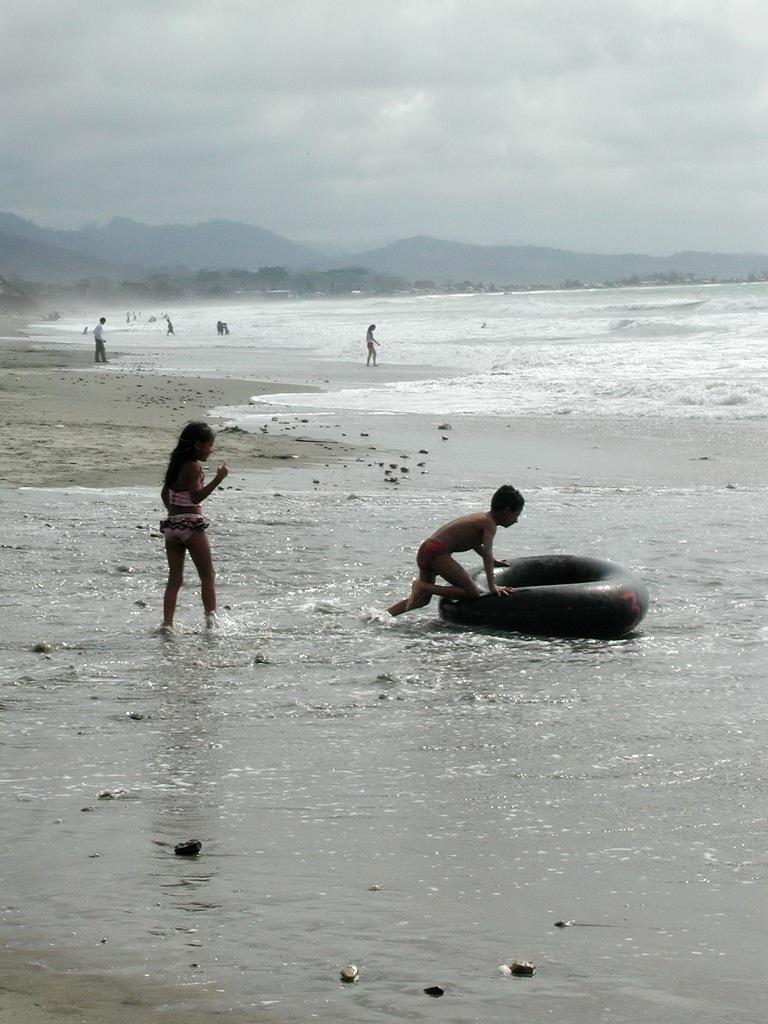Describe this image in one or two sentences. In this image we can see a boy holding a swimming tube and there are people. In the background there is a sea, hills and sky. 